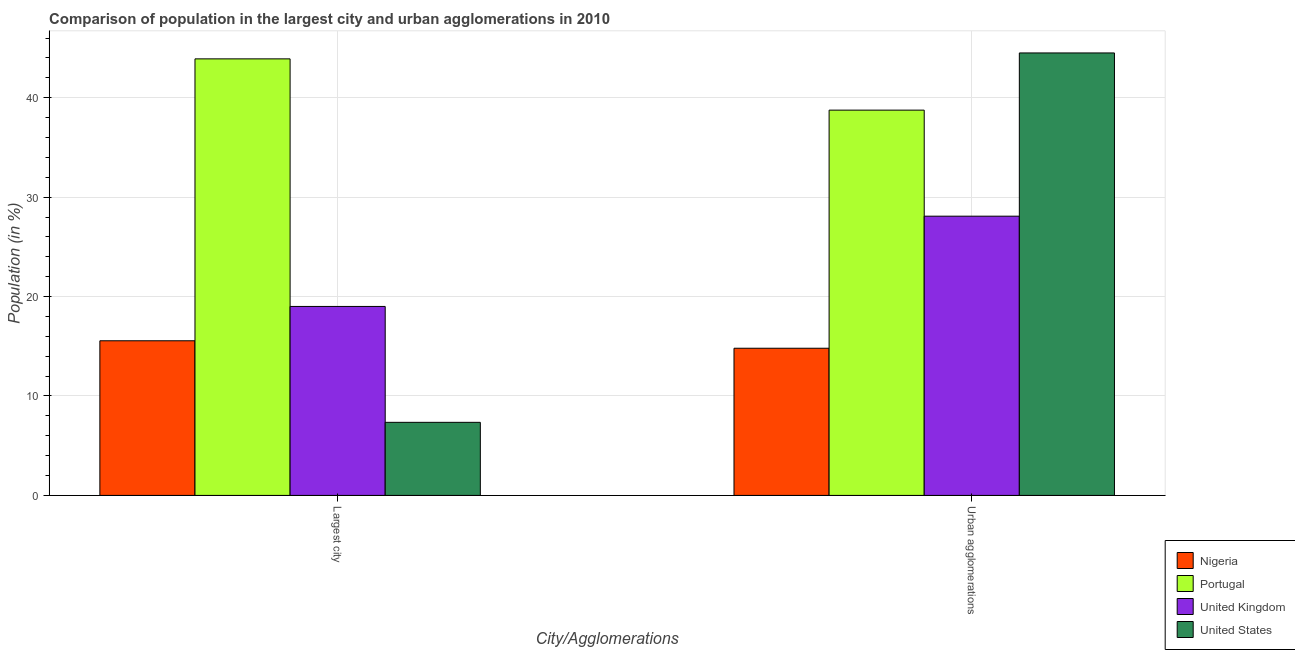How many bars are there on the 1st tick from the left?
Make the answer very short. 4. How many bars are there on the 1st tick from the right?
Ensure brevity in your answer.  4. What is the label of the 2nd group of bars from the left?
Give a very brief answer. Urban agglomerations. What is the population in the largest city in United States?
Give a very brief answer. 7.35. Across all countries, what is the maximum population in urban agglomerations?
Give a very brief answer. 44.5. Across all countries, what is the minimum population in urban agglomerations?
Provide a short and direct response. 14.8. In which country was the population in the largest city maximum?
Your response must be concise. Portugal. In which country was the population in urban agglomerations minimum?
Provide a succinct answer. Nigeria. What is the total population in the largest city in the graph?
Make the answer very short. 85.81. What is the difference between the population in the largest city in United Kingdom and that in Nigeria?
Give a very brief answer. 3.45. What is the difference between the population in urban agglomerations in United States and the population in the largest city in United Kingdom?
Offer a terse response. 25.49. What is the average population in urban agglomerations per country?
Give a very brief answer. 31.53. What is the difference between the population in the largest city and population in urban agglomerations in Nigeria?
Make the answer very short. 0.75. What is the ratio of the population in the largest city in Portugal to that in United States?
Your answer should be compact. 5.97. Is the population in urban agglomerations in Portugal less than that in United Kingdom?
Make the answer very short. No. What does the 2nd bar from the right in Urban agglomerations represents?
Give a very brief answer. United Kingdom. Are all the bars in the graph horizontal?
Your response must be concise. No. What is the difference between two consecutive major ticks on the Y-axis?
Provide a succinct answer. 10. Are the values on the major ticks of Y-axis written in scientific E-notation?
Your answer should be compact. No. How are the legend labels stacked?
Provide a succinct answer. Vertical. What is the title of the graph?
Provide a succinct answer. Comparison of population in the largest city and urban agglomerations in 2010. Does "Botswana" appear as one of the legend labels in the graph?
Make the answer very short. No. What is the label or title of the X-axis?
Make the answer very short. City/Agglomerations. What is the Population (in %) in Nigeria in Largest city?
Your response must be concise. 15.55. What is the Population (in %) in Portugal in Largest city?
Your answer should be very brief. 43.9. What is the Population (in %) in United Kingdom in Largest city?
Offer a terse response. 19.01. What is the Population (in %) of United States in Largest city?
Offer a very short reply. 7.35. What is the Population (in %) in Nigeria in Urban agglomerations?
Ensure brevity in your answer.  14.8. What is the Population (in %) of Portugal in Urban agglomerations?
Your answer should be compact. 38.75. What is the Population (in %) of United Kingdom in Urban agglomerations?
Offer a terse response. 28.08. What is the Population (in %) of United States in Urban agglomerations?
Provide a short and direct response. 44.5. Across all City/Agglomerations, what is the maximum Population (in %) in Nigeria?
Your answer should be very brief. 15.55. Across all City/Agglomerations, what is the maximum Population (in %) in Portugal?
Offer a terse response. 43.9. Across all City/Agglomerations, what is the maximum Population (in %) of United Kingdom?
Provide a succinct answer. 28.08. Across all City/Agglomerations, what is the maximum Population (in %) in United States?
Your answer should be very brief. 44.5. Across all City/Agglomerations, what is the minimum Population (in %) of Nigeria?
Make the answer very short. 14.8. Across all City/Agglomerations, what is the minimum Population (in %) of Portugal?
Keep it short and to the point. 38.75. Across all City/Agglomerations, what is the minimum Population (in %) of United Kingdom?
Offer a terse response. 19.01. Across all City/Agglomerations, what is the minimum Population (in %) of United States?
Your response must be concise. 7.35. What is the total Population (in %) of Nigeria in the graph?
Ensure brevity in your answer.  30.36. What is the total Population (in %) in Portugal in the graph?
Offer a very short reply. 82.65. What is the total Population (in %) in United Kingdom in the graph?
Ensure brevity in your answer.  47.09. What is the total Population (in %) of United States in the graph?
Your answer should be very brief. 51.85. What is the difference between the Population (in %) in Nigeria in Largest city and that in Urban agglomerations?
Ensure brevity in your answer.  0.75. What is the difference between the Population (in %) of Portugal in Largest city and that in Urban agglomerations?
Offer a terse response. 5.16. What is the difference between the Population (in %) of United Kingdom in Largest city and that in Urban agglomerations?
Keep it short and to the point. -9.08. What is the difference between the Population (in %) of United States in Largest city and that in Urban agglomerations?
Provide a short and direct response. -37.15. What is the difference between the Population (in %) of Nigeria in Largest city and the Population (in %) of Portugal in Urban agglomerations?
Make the answer very short. -23.2. What is the difference between the Population (in %) of Nigeria in Largest city and the Population (in %) of United Kingdom in Urban agglomerations?
Your answer should be compact. -12.53. What is the difference between the Population (in %) of Nigeria in Largest city and the Population (in %) of United States in Urban agglomerations?
Offer a very short reply. -28.95. What is the difference between the Population (in %) of Portugal in Largest city and the Population (in %) of United Kingdom in Urban agglomerations?
Make the answer very short. 15.82. What is the difference between the Population (in %) of Portugal in Largest city and the Population (in %) of United States in Urban agglomerations?
Offer a terse response. -0.6. What is the difference between the Population (in %) in United Kingdom in Largest city and the Population (in %) in United States in Urban agglomerations?
Provide a short and direct response. -25.49. What is the average Population (in %) in Nigeria per City/Agglomerations?
Provide a short and direct response. 15.18. What is the average Population (in %) in Portugal per City/Agglomerations?
Offer a very short reply. 41.33. What is the average Population (in %) of United Kingdom per City/Agglomerations?
Offer a very short reply. 23.55. What is the average Population (in %) of United States per City/Agglomerations?
Your response must be concise. 25.93. What is the difference between the Population (in %) of Nigeria and Population (in %) of Portugal in Largest city?
Make the answer very short. -28.35. What is the difference between the Population (in %) of Nigeria and Population (in %) of United Kingdom in Largest city?
Your response must be concise. -3.45. What is the difference between the Population (in %) of Nigeria and Population (in %) of United States in Largest city?
Keep it short and to the point. 8.2. What is the difference between the Population (in %) in Portugal and Population (in %) in United Kingdom in Largest city?
Give a very brief answer. 24.9. What is the difference between the Population (in %) of Portugal and Population (in %) of United States in Largest city?
Your answer should be very brief. 36.55. What is the difference between the Population (in %) in United Kingdom and Population (in %) in United States in Largest city?
Your response must be concise. 11.66. What is the difference between the Population (in %) of Nigeria and Population (in %) of Portugal in Urban agglomerations?
Make the answer very short. -23.95. What is the difference between the Population (in %) in Nigeria and Population (in %) in United Kingdom in Urban agglomerations?
Keep it short and to the point. -13.28. What is the difference between the Population (in %) in Nigeria and Population (in %) in United States in Urban agglomerations?
Provide a short and direct response. -29.7. What is the difference between the Population (in %) in Portugal and Population (in %) in United Kingdom in Urban agglomerations?
Offer a very short reply. 10.66. What is the difference between the Population (in %) in Portugal and Population (in %) in United States in Urban agglomerations?
Offer a terse response. -5.75. What is the difference between the Population (in %) in United Kingdom and Population (in %) in United States in Urban agglomerations?
Offer a very short reply. -16.42. What is the ratio of the Population (in %) in Nigeria in Largest city to that in Urban agglomerations?
Your answer should be very brief. 1.05. What is the ratio of the Population (in %) in Portugal in Largest city to that in Urban agglomerations?
Provide a succinct answer. 1.13. What is the ratio of the Population (in %) in United Kingdom in Largest city to that in Urban agglomerations?
Ensure brevity in your answer.  0.68. What is the ratio of the Population (in %) in United States in Largest city to that in Urban agglomerations?
Your response must be concise. 0.17. What is the difference between the highest and the second highest Population (in %) in Nigeria?
Give a very brief answer. 0.75. What is the difference between the highest and the second highest Population (in %) in Portugal?
Keep it short and to the point. 5.16. What is the difference between the highest and the second highest Population (in %) of United Kingdom?
Make the answer very short. 9.08. What is the difference between the highest and the second highest Population (in %) of United States?
Your answer should be compact. 37.15. What is the difference between the highest and the lowest Population (in %) in Nigeria?
Offer a terse response. 0.75. What is the difference between the highest and the lowest Population (in %) in Portugal?
Offer a very short reply. 5.16. What is the difference between the highest and the lowest Population (in %) in United Kingdom?
Offer a terse response. 9.08. What is the difference between the highest and the lowest Population (in %) in United States?
Give a very brief answer. 37.15. 